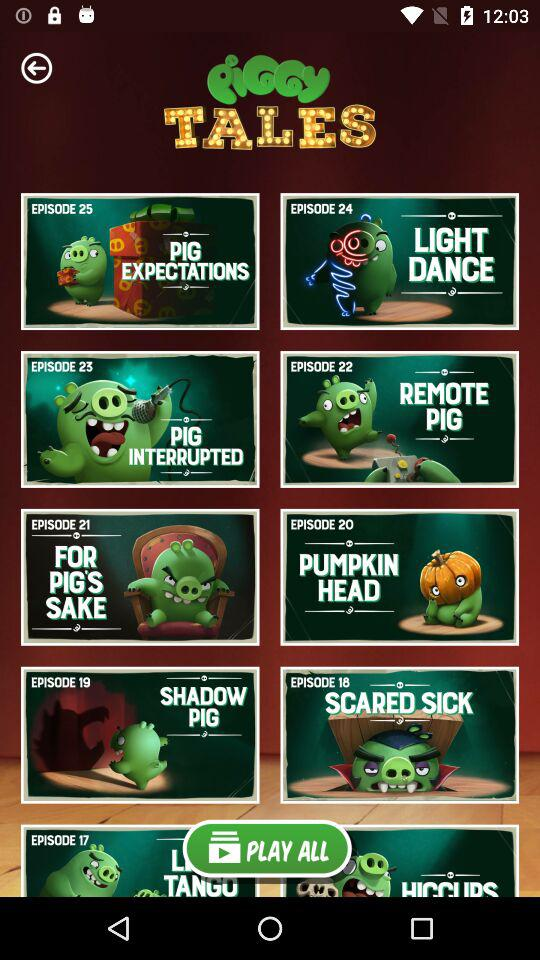What is the application name? The name of the application is "PiGGY TALES". 